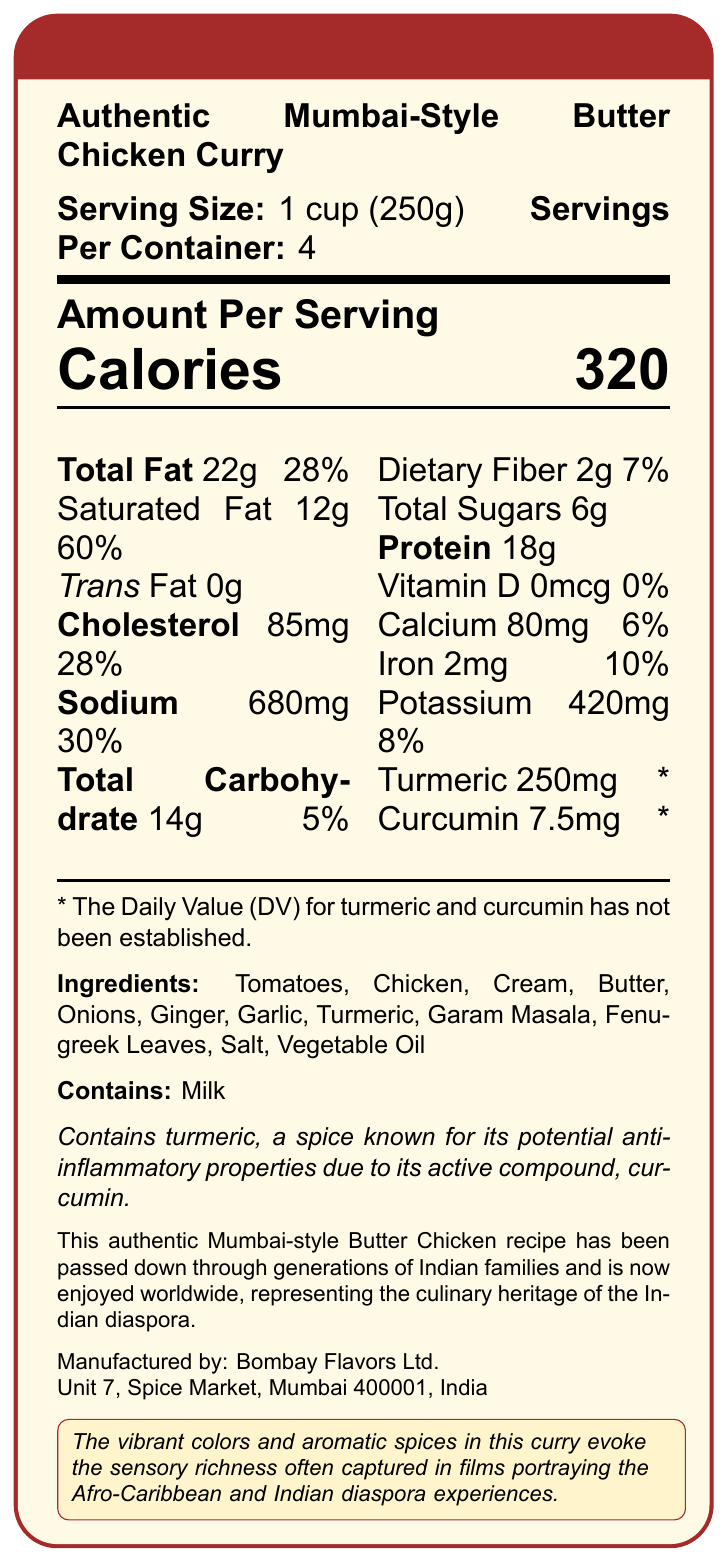what is the serving size? The serving size is explicitly mentioned at the top of the document as 1 cup (250g).
Answer: 1 cup (250g) how many servings are in the container? The servings per container are listed as 4, right next to the serving size.
Answer: 4 How many calories are in one serving? The number of calories per serving is prominently displayed under the "Amount Per Serving" section.
Answer: 320 what is the total fat content per serving? The total fat per serving is listed as 22g.
Answer: 22g what percentage of daily value does the saturated fat contribute? The saturated fat's daily value percentage is listed as 60% next to the saturated fat amount.
Answer: 60% which ingredient is known for its potential anti-inflammatory properties? A. Onions B. Garlic C. Turmeric The document mentions that turmeric is known for its potential anti-inflammatory properties due to its active compound, curcumin.
Answer: C How much turmeric does each serving contain? The amount of turmeric per serving is listed as 250mg.
Answer: 250mg does the product contain any allergens? The product contains milk, as indicated in the "Contains" section.
Answer: Yes what is the content of curcumin in each serving? The amount of curcumin per serving is listed as 7.5mg.
Answer: 7.5mg what type of dish is described in the document? The product name, "Authentic Mumbai-Style Butter Chicken Curry," is given at the top of the document.
Answer: Authentic Mumbai-Style Butter Chicken what is the sodium content per serving? The sodium content per serving is listed as 680mg.
Answer: 680mg how much dietary fiber is in one serving? The dietary fiber content per serving is listed as 2g.
Answer: 2g which company manufactures this product? A. Bombay Flavors Ltd. B. Mumbai Spice Co. C. Indian Taste Makers The manufacturer is listed as Bombay Flavors Ltd., as seen at the bottom of the document.
Answer: A describe the cultural significance and inspiration behind this product The document details the cultural significance by stating that the recipe has been handed down through generations and represents Indian diaspora culinary heritage. It also highlights how the curry's vibrant colors and spices inspire sensory richness, relevant to films about Afro-Caribbean and Indian diaspora experiences.
Answer: This authentic Mumbai-style Butter Chicken recipe has been passed down through generations of Indian families and is now enjoyed worldwide, representing the culinary heritage of the Indian diaspora. The vibrant colors and aromatic spices in this curry evoke the sensory richness often captured in films portraying the Afro-Caribbean and Indian diaspora experiences. what is the address of the manufacturer? The manufacturer's address is listed at the bottom of the document.
Answer: Unit 7, Spice Market, Mumbai 400001, India what is the daily value percentage for iron? The daily value percentage for iron is listed as 10%.
Answer: 10% does the document specify the daily value for turmeric and curcumin? The document explicitly states that the daily value for turmeric and curcumin has not been established.
Answer: No what is the source of the dairy allergen in this product? The dairy allergen likely comes from cream and butter, both of which are common dairy products and are listed in the ingredients.
Answer: Cream, Butter what is the calorie content of the entire container? Since there are 4 servings per container, and each serving has 320 calories, the entire container would contain 4 * 320 = 1280 calories.
Answer: 1280 calories Can the total carbohydrates in one serving affect a low-carb diet significantly? The impact on a low-carb diet depends on the total daily carbohydrate intake allowed by the diet plan, which is not provided in the document.
Answer: Not enough information 